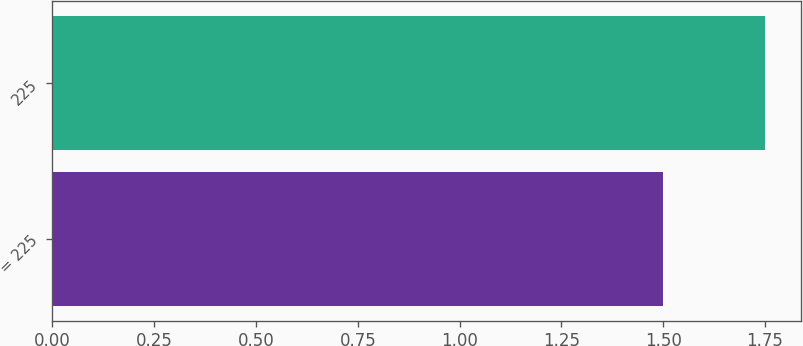Convert chart to OTSL. <chart><loc_0><loc_0><loc_500><loc_500><bar_chart><fcel>= 225<fcel>225<nl><fcel>1.5<fcel>1.75<nl></chart> 